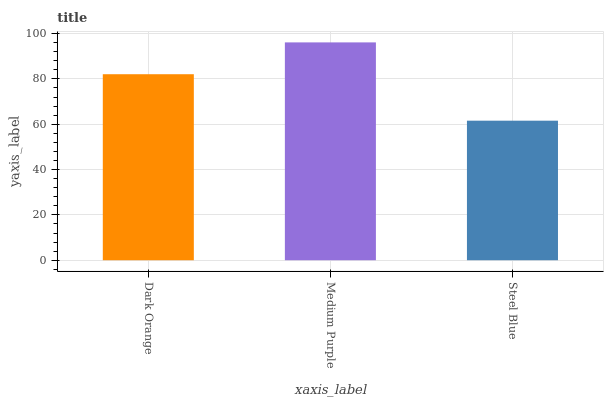Is Steel Blue the minimum?
Answer yes or no. Yes. Is Medium Purple the maximum?
Answer yes or no. Yes. Is Medium Purple the minimum?
Answer yes or no. No. Is Steel Blue the maximum?
Answer yes or no. No. Is Medium Purple greater than Steel Blue?
Answer yes or no. Yes. Is Steel Blue less than Medium Purple?
Answer yes or no. Yes. Is Steel Blue greater than Medium Purple?
Answer yes or no. No. Is Medium Purple less than Steel Blue?
Answer yes or no. No. Is Dark Orange the high median?
Answer yes or no. Yes. Is Dark Orange the low median?
Answer yes or no. Yes. Is Medium Purple the high median?
Answer yes or no. No. Is Steel Blue the low median?
Answer yes or no. No. 